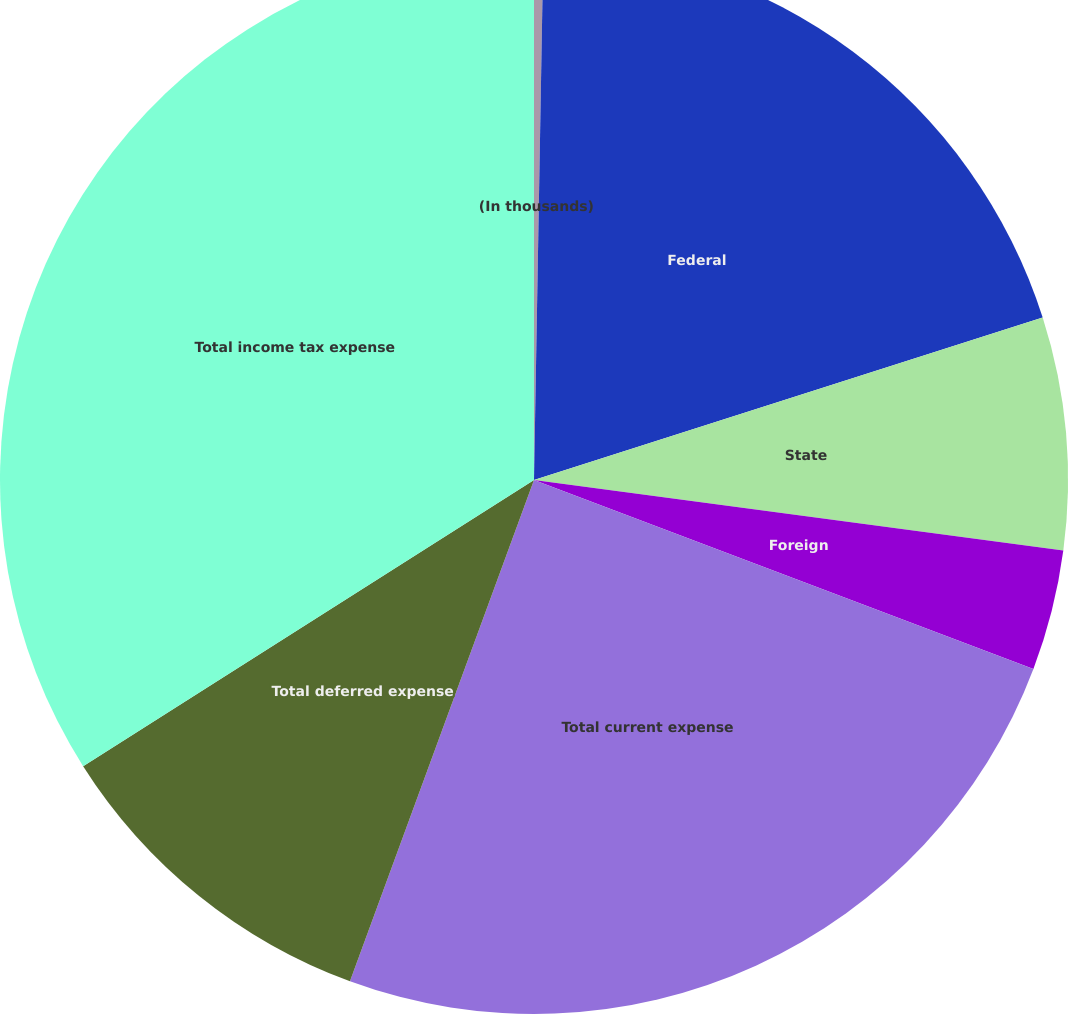Convert chart. <chart><loc_0><loc_0><loc_500><loc_500><pie_chart><fcel>(In thousands)<fcel>Federal<fcel>State<fcel>Foreign<fcel>Total current expense<fcel>Total deferred expense<fcel>Total income tax expense<nl><fcel>0.28%<fcel>19.8%<fcel>7.03%<fcel>3.65%<fcel>24.84%<fcel>10.4%<fcel>34.0%<nl></chart> 